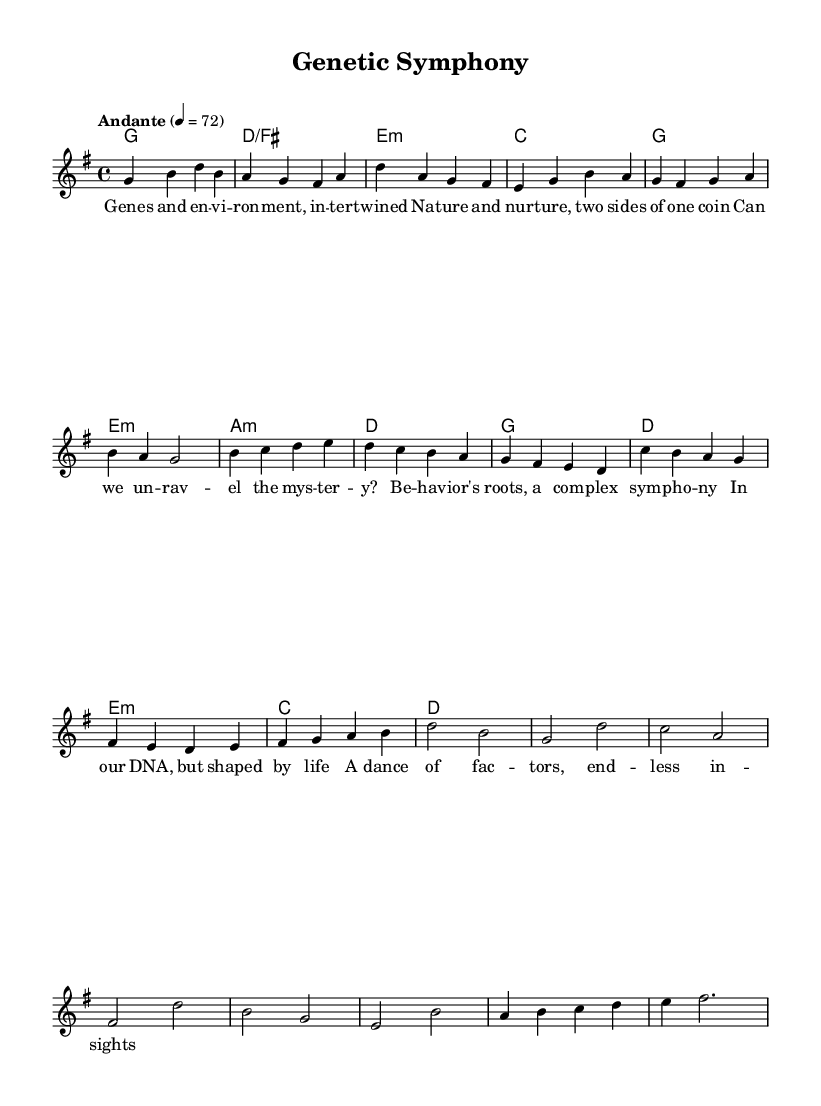What is the key signature of this music? The key signature of this music is G major, which has one sharp (F#). This can be identified from the global section at the top of the code, where it specifies \key g \major.
Answer: G major What is the time signature of the music? The time signature is 4/4, which indicates that there are four beats per measure. This is shown at the beginning of the global section with \time 4/4.
Answer: 4/4 What is the tempo marking for this piece? The tempo marking for this piece is "Andante," which suggests a moderately slow pace. This is explicitly mentioned in the global section as \tempo "Andante" 4 = 72, where the 72 indicates the beats per minute.
Answer: Andante How many measures are there in the chorus? To find the number of measures in the chorus, we count the measures containing the melody and corresponding lyrics. In the section labeled "Chorus," there are 8 measures.
Answer: 8 What are the primary themes reflected in the lyrics of this piece? The primary themes in the lyrics revolve around the concepts of nature versus nurture, as illustrated through words like "Genes and environment" and "Behavior's roots." This theme is explained through the verses in the lyric sections.
Answer: Nature vs. nurture What type of chord progression is primarily used in the verses? The chord progression in the verses follows a pattern that generally ascends and resolves. The chords are G major, D/F♯, E minor, and C major. The harmonies detail the support for the melody throughout the verse.
Answer: G, D/F♯, E minor, C What makes this piece characteristic of K-Pop ballads? This piece is characteristic of K-Pop ballads through its emotional lyrical content that deals with introspective themes, along with a contemplative melody supported by harmonically rich chords. The lyrics focus on personal and universal themes, which is typical in K-Pop ballads.
Answer: Emotional themes and melodic richness 